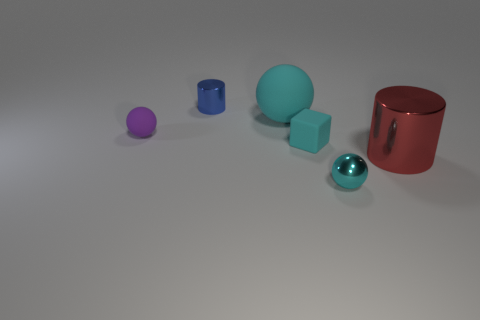Subtract all big cyan balls. How many balls are left? 2 Add 3 red cylinders. How many objects exist? 9 Subtract all red cylinders. How many cylinders are left? 1 Subtract 1 balls. How many balls are left? 2 Subtract all big green blocks. Subtract all blue objects. How many objects are left? 5 Add 3 small purple things. How many small purple things are left? 4 Add 4 matte cylinders. How many matte cylinders exist? 4 Subtract 0 green spheres. How many objects are left? 6 Subtract all cubes. How many objects are left? 5 Subtract all brown cylinders. Subtract all brown blocks. How many cylinders are left? 2 